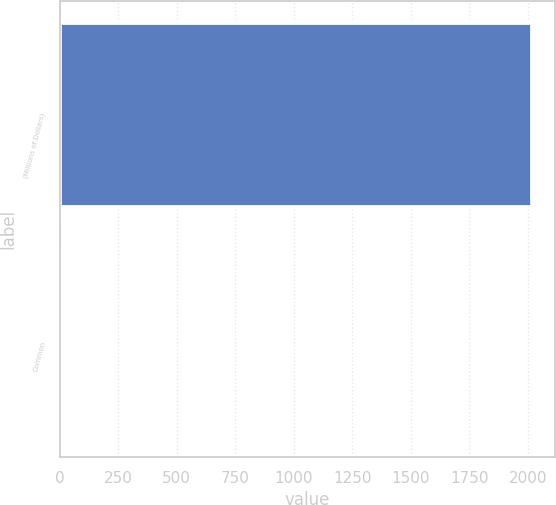Convert chart. <chart><loc_0><loc_0><loc_500><loc_500><bar_chart><fcel>(Millions of Dollars)<fcel>Common<nl><fcel>2013<fcel>2<nl></chart> 